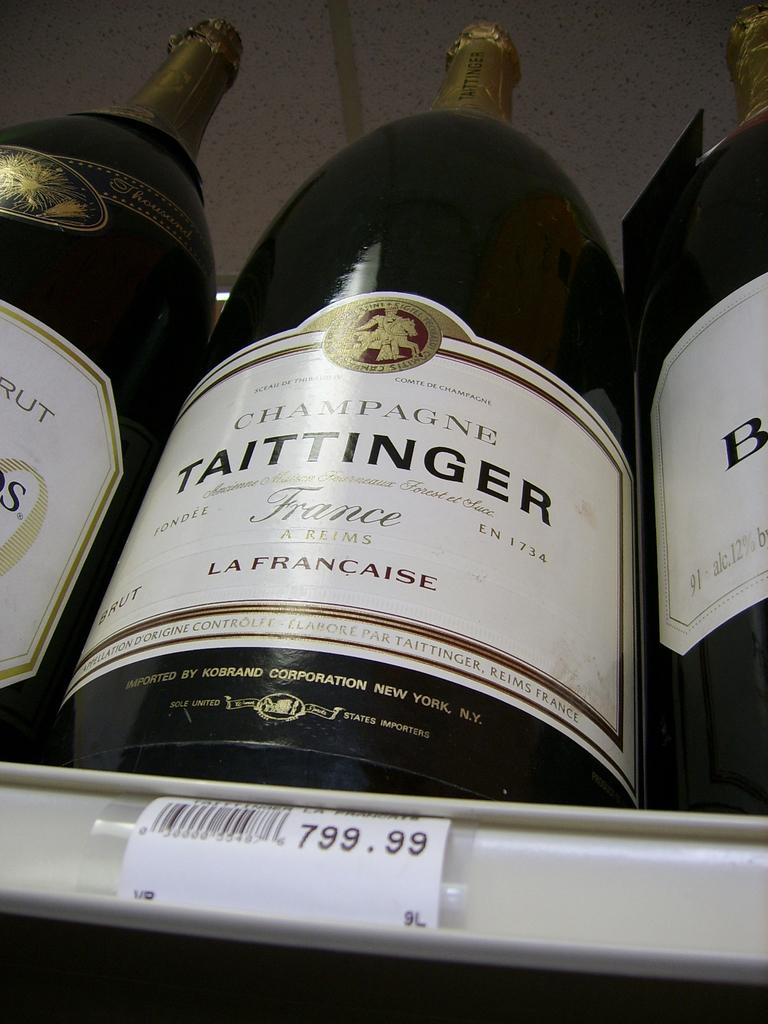What is the price?
Make the answer very short. 799.99. 